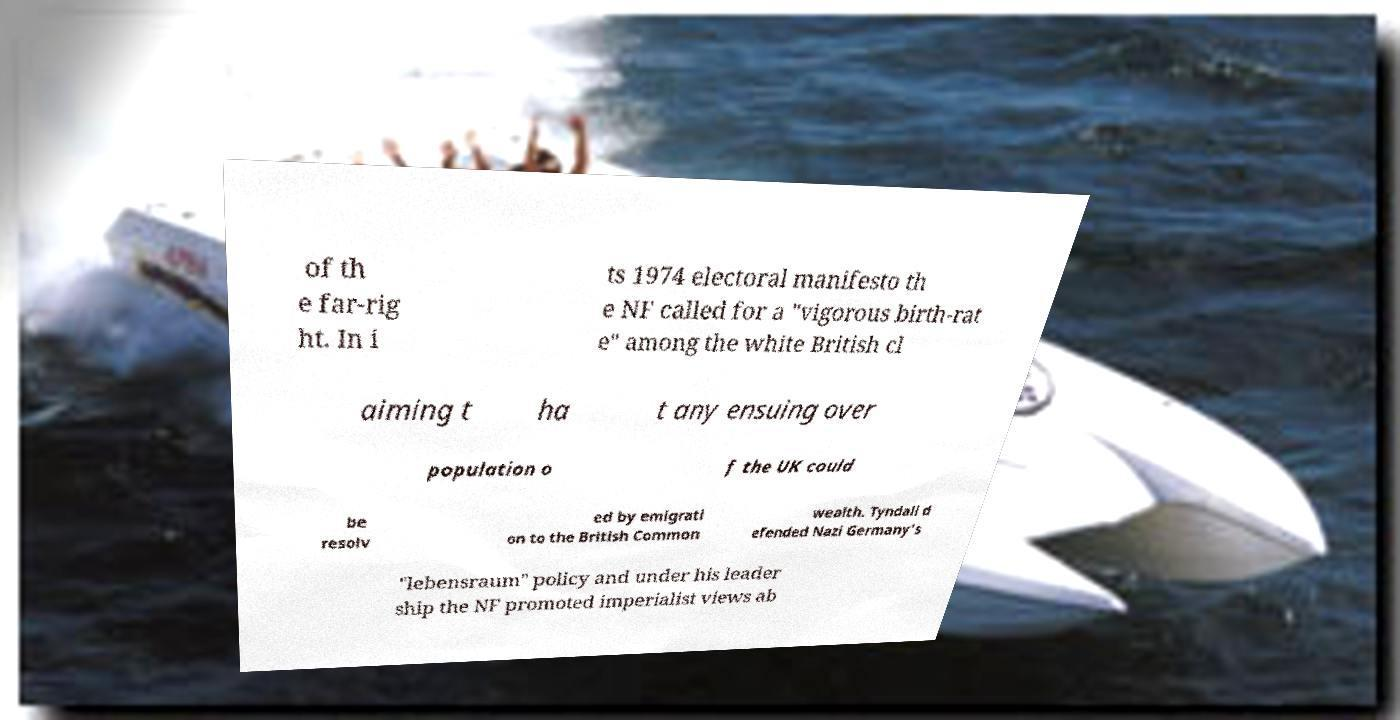Could you assist in decoding the text presented in this image and type it out clearly? of th e far-rig ht. In i ts 1974 electoral manifesto th e NF called for a "vigorous birth-rat e" among the white British cl aiming t ha t any ensuing over population o f the UK could be resolv ed by emigrati on to the British Common wealth. Tyndall d efended Nazi Germany's "lebensraum" policy and under his leader ship the NF promoted imperialist views ab 